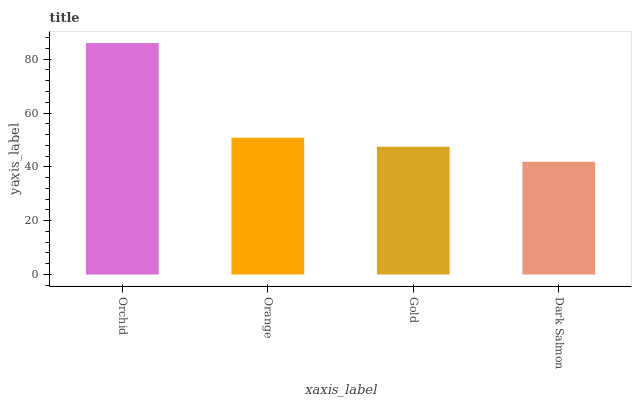Is Dark Salmon the minimum?
Answer yes or no. Yes. Is Orchid the maximum?
Answer yes or no. Yes. Is Orange the minimum?
Answer yes or no. No. Is Orange the maximum?
Answer yes or no. No. Is Orchid greater than Orange?
Answer yes or no. Yes. Is Orange less than Orchid?
Answer yes or no. Yes. Is Orange greater than Orchid?
Answer yes or no. No. Is Orchid less than Orange?
Answer yes or no. No. Is Orange the high median?
Answer yes or no. Yes. Is Gold the low median?
Answer yes or no. Yes. Is Dark Salmon the high median?
Answer yes or no. No. Is Orange the low median?
Answer yes or no. No. 